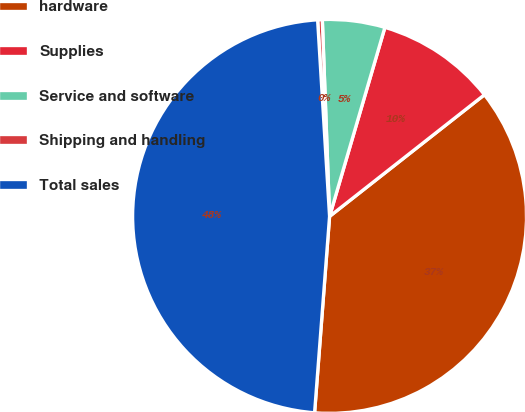<chart> <loc_0><loc_0><loc_500><loc_500><pie_chart><fcel>hardware<fcel>Supplies<fcel>Service and software<fcel>Shipping and handling<fcel>Total sales<nl><fcel>36.81%<fcel>9.87%<fcel>5.12%<fcel>0.38%<fcel>47.82%<nl></chart> 